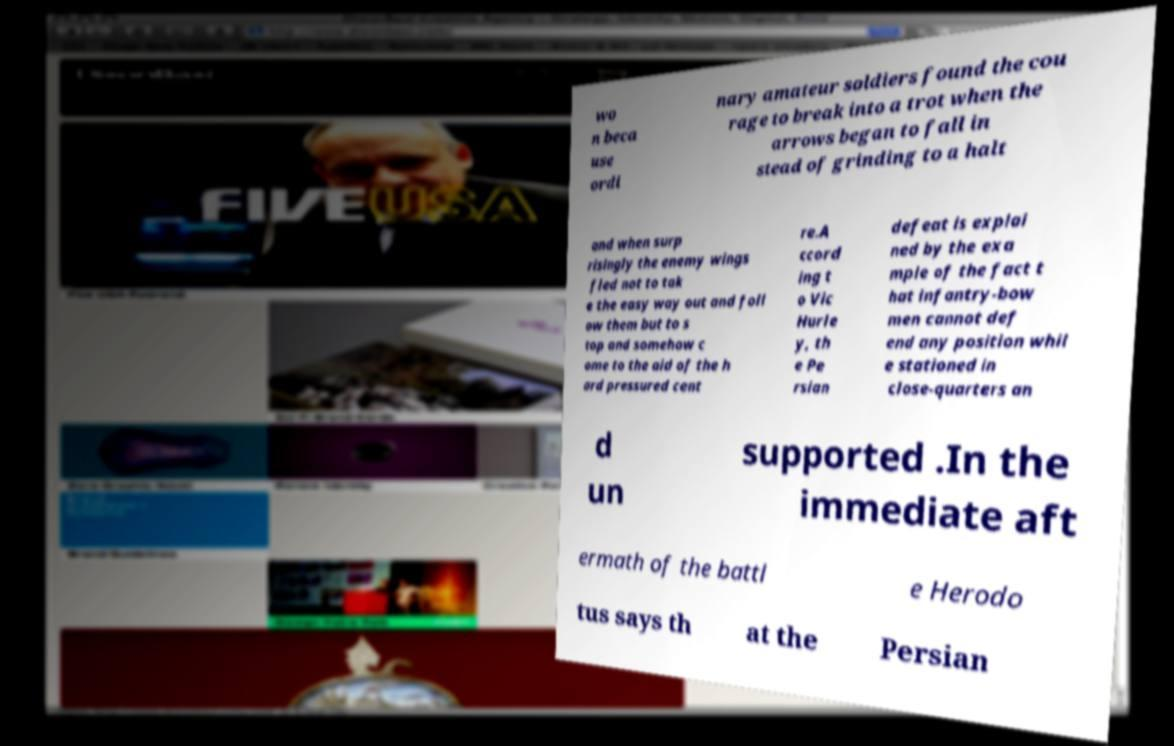Please read and relay the text visible in this image. What does it say? wo n beca use ordi nary amateur soldiers found the cou rage to break into a trot when the arrows began to fall in stead of grinding to a halt and when surp risingly the enemy wings fled not to tak e the easy way out and foll ow them but to s top and somehow c ome to the aid of the h ard pressured cent re.A ccord ing t o Vic Hurle y, th e Pe rsian defeat is explai ned by the exa mple of the fact t hat infantry-bow men cannot def end any position whil e stationed in close-quarters an d un supported .In the immediate aft ermath of the battl e Herodo tus says th at the Persian 